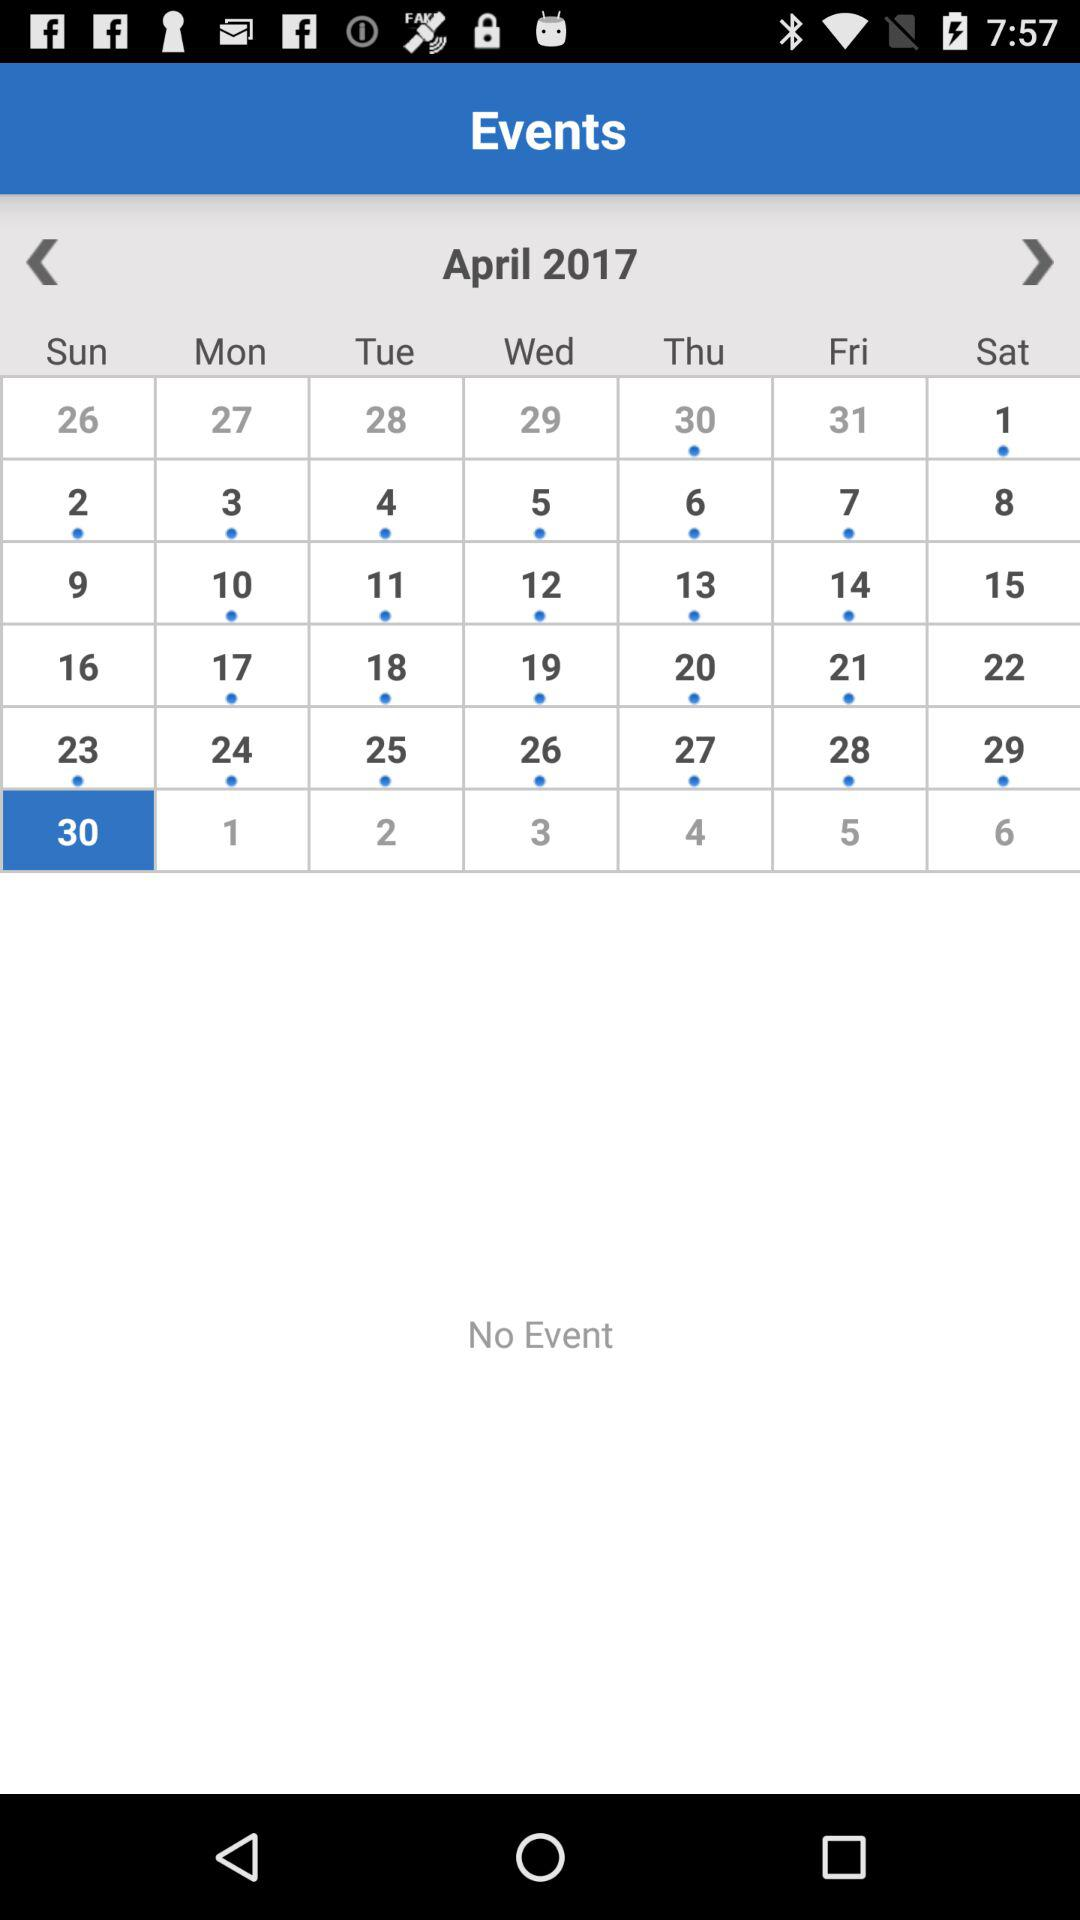What is the selected date? The selected date is Sunday, April 30, 2017. 